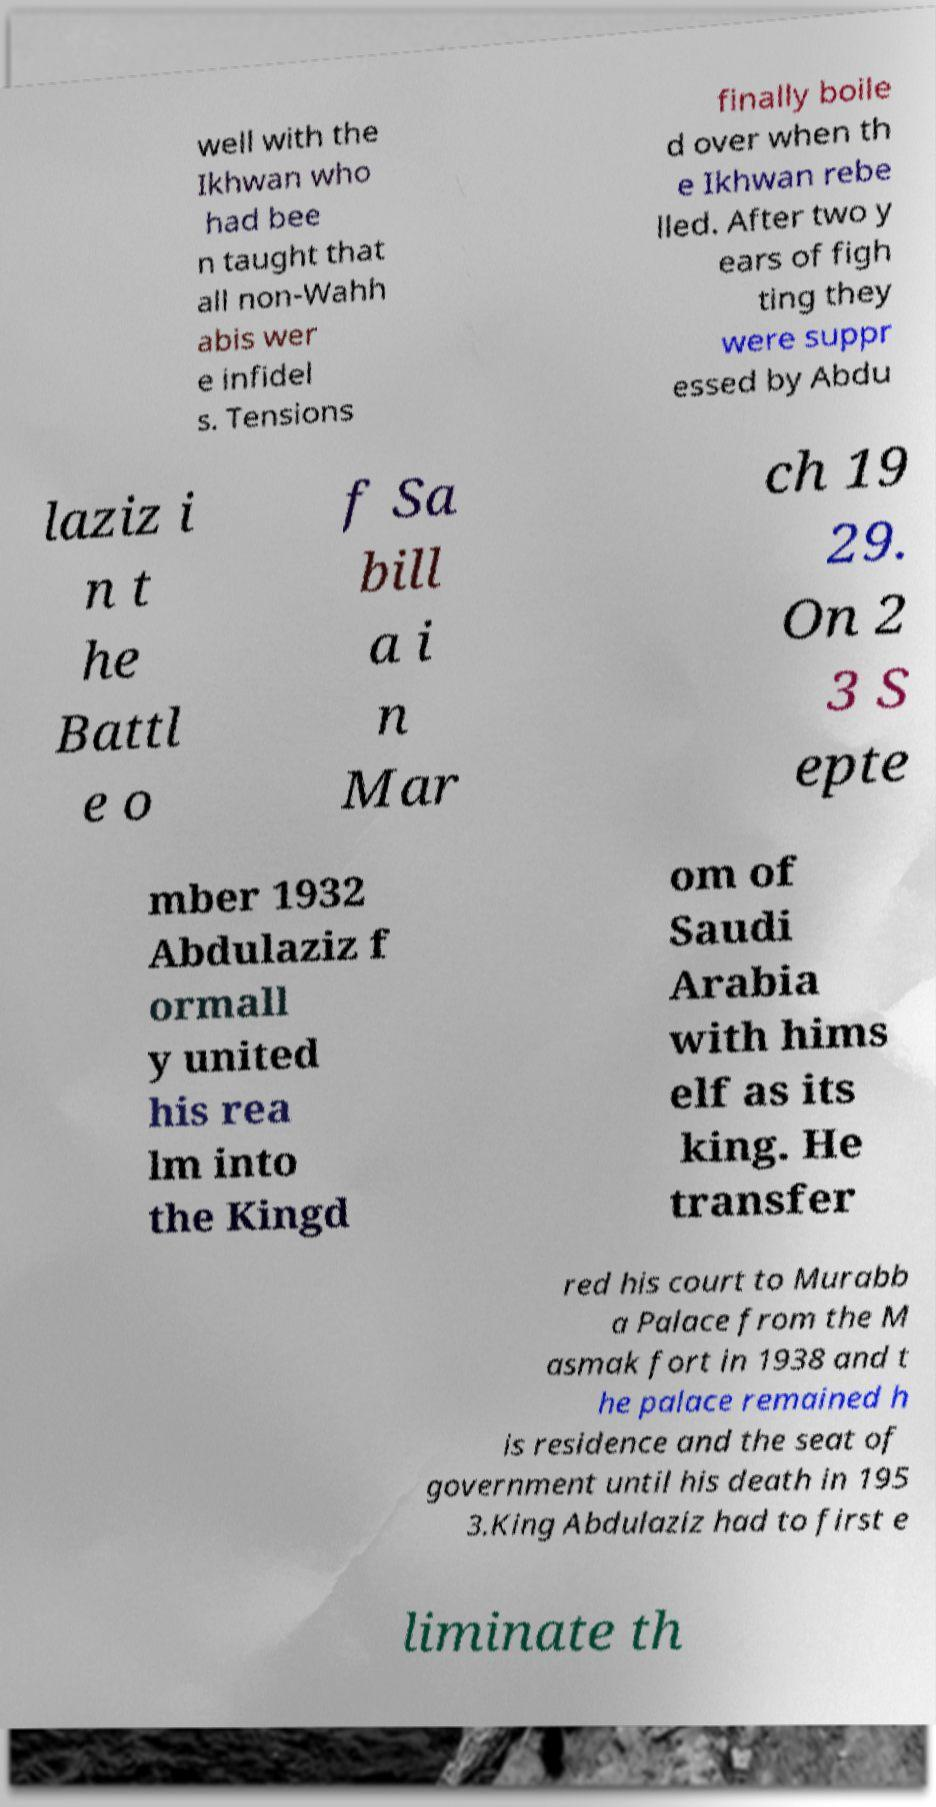Please read and relay the text visible in this image. What does it say? well with the Ikhwan who had bee n taught that all non-Wahh abis wer e infidel s. Tensions finally boile d over when th e Ikhwan rebe lled. After two y ears of figh ting they were suppr essed by Abdu laziz i n t he Battl e o f Sa bill a i n Mar ch 19 29. On 2 3 S epte mber 1932 Abdulaziz f ormall y united his rea lm into the Kingd om of Saudi Arabia with hims elf as its king. He transfer red his court to Murabb a Palace from the M asmak fort in 1938 and t he palace remained h is residence and the seat of government until his death in 195 3.King Abdulaziz had to first e liminate th 